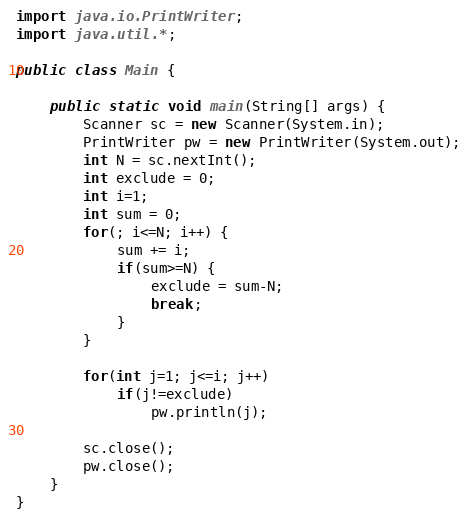Convert code to text. <code><loc_0><loc_0><loc_500><loc_500><_Java_>import java.io.PrintWriter;
import java.util.*;

public class Main {

	public static void main(String[] args) {
		Scanner sc = new Scanner(System.in);
		PrintWriter pw = new PrintWriter(System.out);
		int N = sc.nextInt();
		int exclude = 0;
		int i=1;
		int sum = 0;
		for(; i<=N; i++) {
			sum += i;
			if(sum>=N) {
				exclude = sum-N;
				break;
			}
		}
		
		for(int j=1; j<=i; j++)
			if(j!=exclude)
				pw.println(j);
		
		sc.close();
		pw.close();
	}
}
</code> 